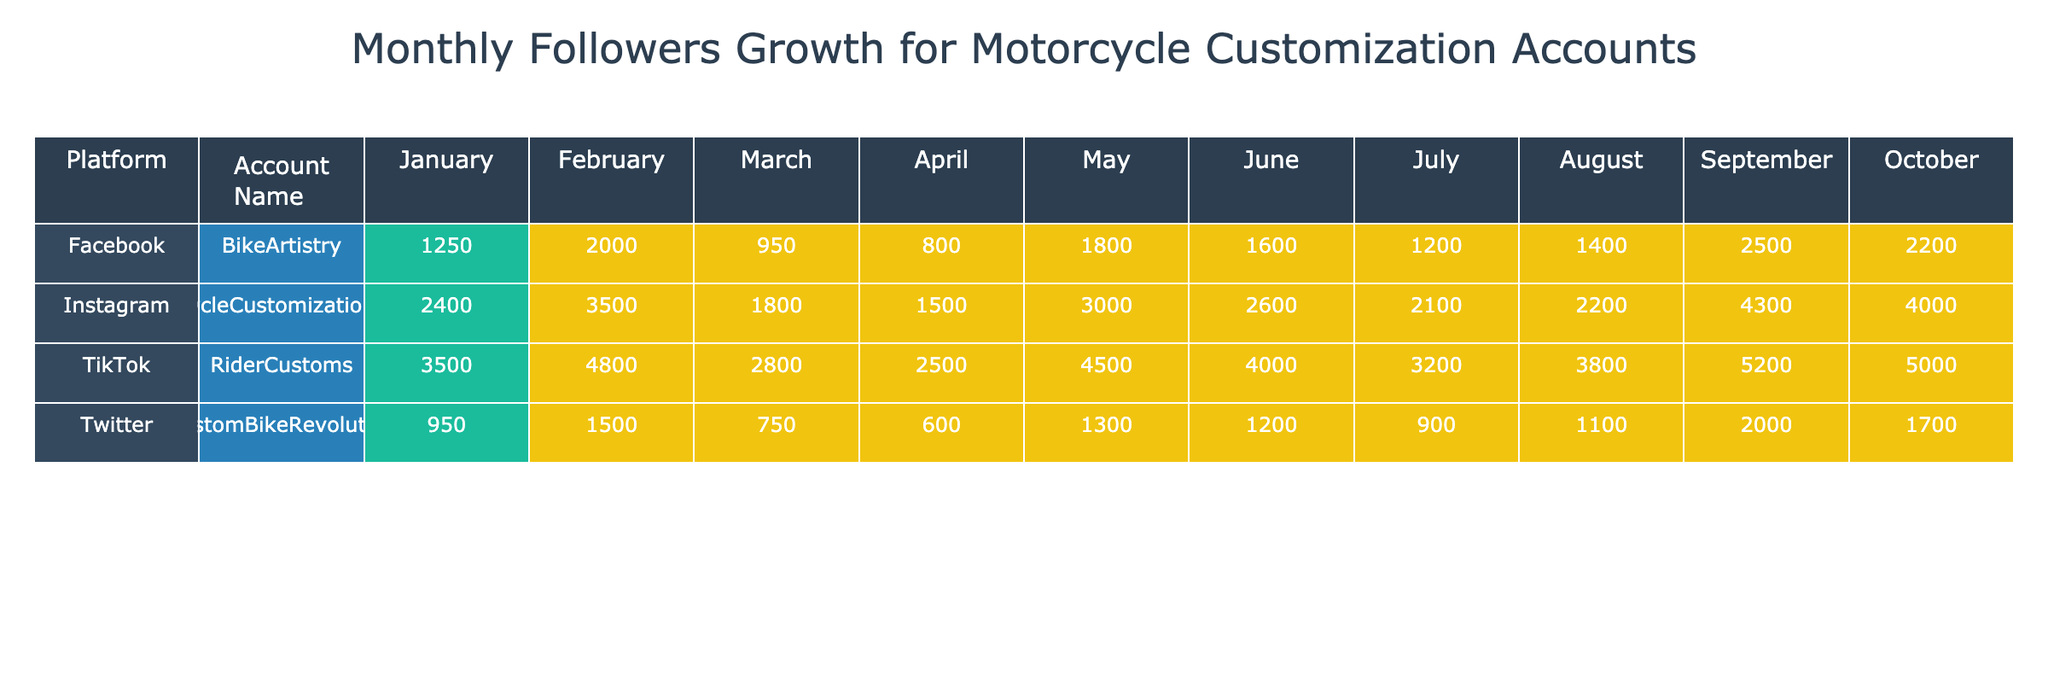What's the total follower growth for the MotorcycleCustomizationMaster account on Instagram in July? The follower growth for July is explicitly listed in the table, showing a value of 3000 for the MotorcycleCustomizationMaster account on Instagram.
Answer: 3000 What content type had the highest follower growth on TikTok in September? According to the table, the content type "Live Custom Builds" corresponds with a follower growth of 5000 for RiderCustoms on TikTok in September.
Answer: Live Custom Builds Which platform had the highest average follower growth over the months? To find the average growth per platform, I sum the follower growth for each and divide by the number of months. Instagram: (1500 + 1800 + 2100 + 2400 + 2200 + 2600 + 3000 + 3500 + 4000 + 4300) / 10 = 2650. Facebook: (800 + 950 + 1200 + 1250 + 1400 + 1600 + 1800 + 2000 + 2200 + 2500) / 10 = 1660. Twitter: (600 + 750 + 900 + 950 + 1100 + 1200 + 1300 + 1500 + 1700 + 2000) / 10 = 1220. TikTok: (2500 + 2800 + 3200 + 3500 + 3800 + 4000 + 4500 + 4800 + 5000 + 5200) / 10 = 3990. Therefore, TikTok had the highest average growth.
Answer: TikTok Did the BikeArtistry account on Facebook consistently grow its followers each month? By reviewing the follower growth for BikeArtistry on Facebook, I observe that all months' follower growth increased (from 800 in January to 2500 in October), showing consistent growth without any declines.
Answer: Yes What was the increase in follower growth from March to April for the CustomBikeRevolution account on Twitter? The follower growth for March is 900, and for April, it is 950. The increase is calculated as 950 - 900 = 50.
Answer: 50 Which platform saw the lowest follower growth in January? By examining the January values in the table, the follower growths are: Instagram - 1500, Facebook - 800, Twitter - 600, TikTok - 2500. The lowest growth is from the Twitter account, which had 600.
Answer: Twitter What is the total follower growth for the account on Facebook in the first half of the year? The monthly follower growth for Facebook from January to June is: 800 + 950 + 1200 + 1250 + 1400 + 1600 = 5150.
Answer: 5150 For which account was the largest single monthly follower increase recorded, and what was that increase? Upon analyzing the changes month-to-month, August shows the largest single growth for MotorcycleCustomizationMaster on Instagram, which is 500 from July (3000) to August (3500).
Answer: MotorcycleCustomizationMaster, 500 How many more followers did the RiderCustoms account gain from April to October compared to the MotorcycleCustomizationMaster in the same timeframe? For RiderCustoms, followers grew from 3500 in April to 5200 in October, which is an increase of 1700. For MotorcycleCustomizationMaster, followers grew from 2400 to 4300, which is 1900. The difference is calculated as 1900 (MotorcycleCustomizationMaster) - 1700 (RiderCustoms) = 200.
Answer: 200 Which account had a September follower growth of 4000 on Instagram? From the table, the MotorcycleCustomizationMaster account on Instagram was shown to have a follower growth of 4000 in September.
Answer: MotorcycleCustomizationMaster 